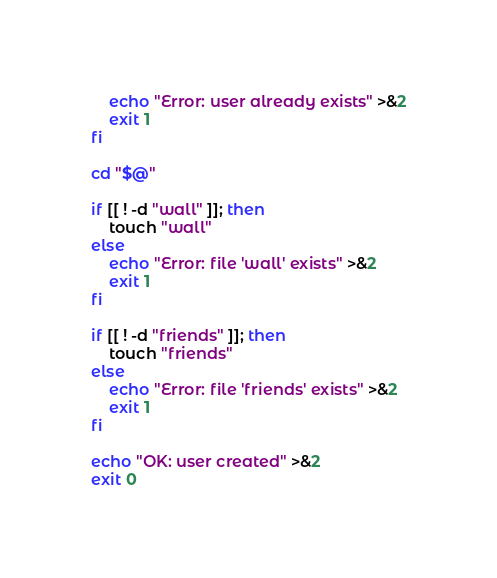<code> <loc_0><loc_0><loc_500><loc_500><_Bash_>	echo "Error: user already exists" >&2
	exit 1
fi
	 
cd "$@"

if [[ ! -d "wall" ]]; then
	touch "wall"
else
	echo "Error: file 'wall' exists" >&2
	exit 1
fi

if [[ ! -d "friends" ]]; then
	touch "friends"
else
	echo "Error: file 'friends' exists" >&2
	exit 1
fi

echo "OK: user created" >&2
exit 0
</code> 